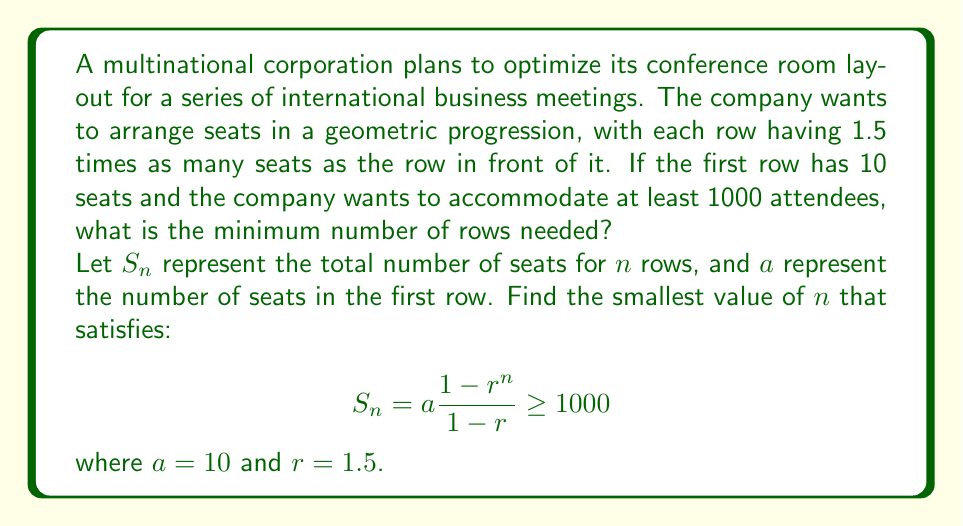Solve this math problem. To solve this problem, we'll use the formula for the sum of a geometric series and solve for $n$ using an iterative approach.

1) The formula for the sum of a geometric series is:

   $$S_n = a\frac{1-r^n}{1-r}$$

   where $a$ is the first term, $r$ is the common ratio, and $n$ is the number of terms.

2) We're given that $a = 10$ and $r = 1.5$. Substituting these values:

   $$S_n = 10\frac{1-1.5^n}{1-1.5} = 10\frac{1-1.5^n}{-0.5} = 20(1.5^n - 1)$$

3) We need to find the smallest $n$ for which $S_n \geq 1000$:

   $$20(1.5^n - 1) \geq 1000$$

4) Solving for $1.5^n$:

   $$1.5^n - 1 \geq 50$$
   $$1.5^n \geq 51$$

5) Taking the logarithm of both sides:

   $$n \log 1.5 \geq \log 51$$
   $$n \geq \frac{\log 51}{\log 1.5} \approx 8.21$$

6) Since $n$ must be a whole number, we round up to the next integer.

Therefore, the minimum number of rows needed is 9.

To verify:
$$S_9 = 20(1.5^9 - 1) \approx 1025.79$$

This confirms that 9 rows will accommodate at least 1000 attendees.
Answer: The minimum number of rows needed is 9. 